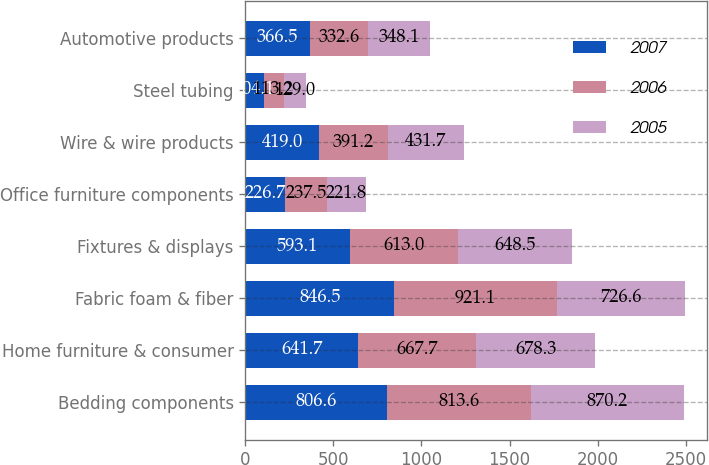Convert chart to OTSL. <chart><loc_0><loc_0><loc_500><loc_500><stacked_bar_chart><ecel><fcel>Bedding components<fcel>Home furniture & consumer<fcel>Fabric foam & fiber<fcel>Fixtures & displays<fcel>Office furniture components<fcel>Wire & wire products<fcel>Steel tubing<fcel>Automotive products<nl><fcel>2007<fcel>806.6<fcel>641.7<fcel>846.5<fcel>593.1<fcel>226.7<fcel>419<fcel>104.1<fcel>366.5<nl><fcel>2006<fcel>813.6<fcel>667.7<fcel>921.1<fcel>613<fcel>237.5<fcel>391.2<fcel>113.2<fcel>332.6<nl><fcel>2005<fcel>870.2<fcel>678.3<fcel>726.6<fcel>648.5<fcel>221.8<fcel>431.7<fcel>129<fcel>348.1<nl></chart> 